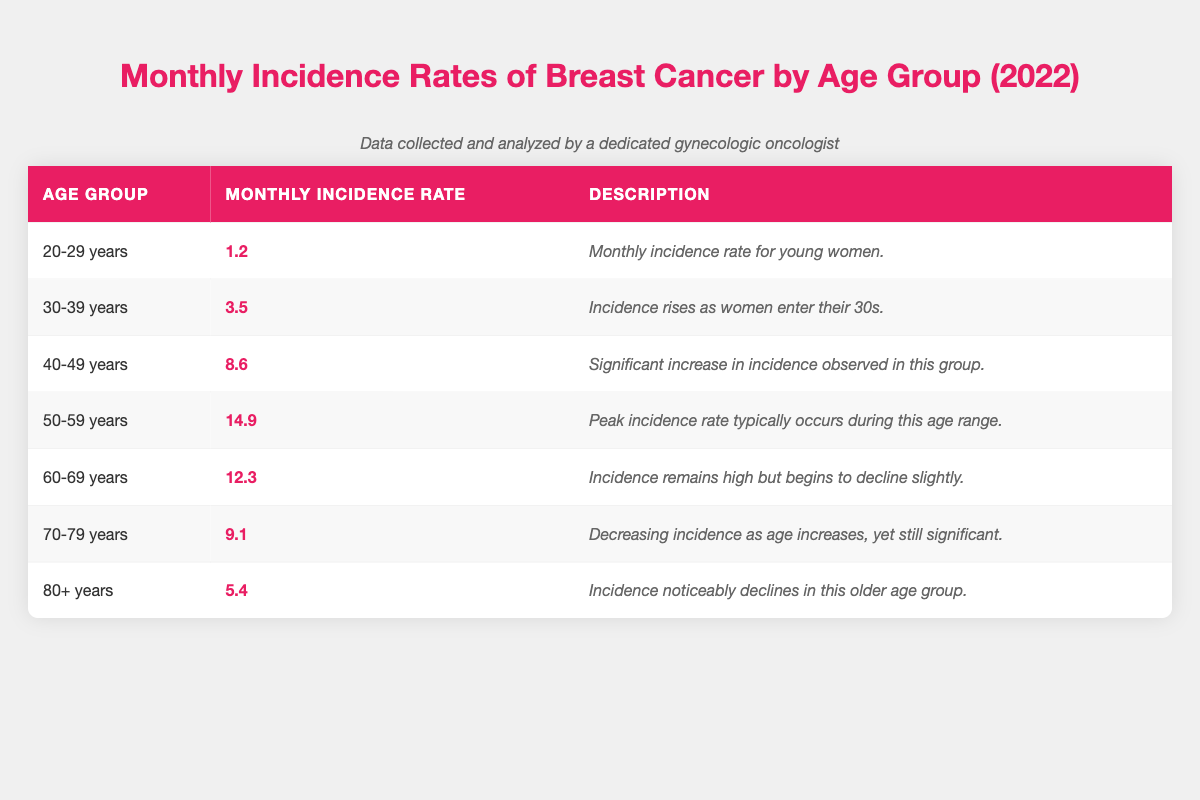What's the monthly incidence rate of breast cancer for women aged 50-59? According to the table, the monthly incidence rate for the age group 50-59 years is 14.9.
Answer: 14.9 Which age group has the highest monthly incidence rate of breast cancer? The age group with the highest monthly incidence rate is 50-59 years, with a rate of 14.9.
Answer: 50-59 years Is the monthly incidence rate for women aged 80+ years higher than for those aged 70-79 years? The monthly incidence rate for 80+ years is 5.4, while for 70-79 years it is 9.1. Since 5.4 is less than 9.1, the statement is false.
Answer: No What is the total monthly incidence rate for women aged 40-49 and 50-59 combined? Adding the monthly incidence rates for both groups: 8.6 (40-49 years) + 14.9 (50-59 years) = 23.5.
Answer: 23.5 Is there a significant decline in breast cancer incidence from the 50-59 age group to the 60-69 age group? The monthly incidence rate drops from 14.9 (50-59) to 12.3 (60-69), indicating a decline, but it is not described as significant. Thus, while there is a decrease, it may not be considered significant.
Answer: Yes, but not significant What is the average monthly incidence rate across all age groups? To find the average, sum all the rates: 1.2 + 3.5 + 8.6 + 14.9 + 12.3 + 9.1 + 5.4 = 55.0. Then divide by the number of age groups (7): 55.0 / 7 ≈ 7.86.
Answer: Approximately 7.86 Which age group has the lowest monthly incidence rate? The age group with the lowest rate is 20-29 years with a monthly incidence rate of 1.2.
Answer: 20-29 years How much higher is the monthly incidence rate for the 40-49 age group compared to the 20-29 age group? The difference between the incidence rates is 8.6 (40-49) - 1.2 (20-29) = 7.4.
Answer: 7.4 Does the monthly incidence rate increase continuously with age up to 60-69? The rates increase from 20-29 years to 50-59 years, but there is a decline from 50-59 years to 60-69 years (14.9 to 12.3), indicating it doesn't increase continuously.
Answer: No 